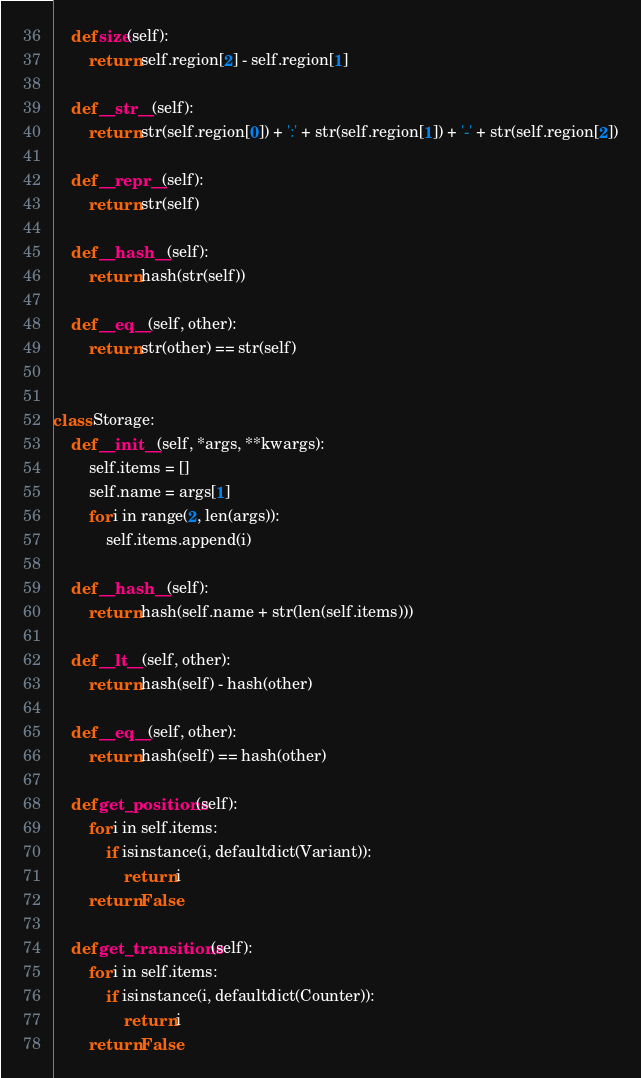<code> <loc_0><loc_0><loc_500><loc_500><_Python_>
    def size(self):
        return self.region[2] - self.region[1]

    def __str__(self):
        return str(self.region[0]) + ':' + str(self.region[1]) + '-' + str(self.region[2])

    def __repr__(self):
        return str(self)

    def __hash__(self):
        return hash(str(self))

    def __eq__(self, other):
        return str(other) == str(self)


class Storage:
    def __init__(self, *args, **kwargs):
        self.items = []
        self.name = args[1]
        for i in range(2, len(args)):
            self.items.append(i)

    def __hash__(self):
        return hash(self.name + str(len(self.items)))

    def __lt__(self, other):
        return hash(self) - hash(other)

    def __eq__(self, other):
        return hash(self) == hash(other)

    def get_positions(self):
        for i in self.items:
            if isinstance(i, defaultdict(Variant)):
                return i
        return False

    def get_transitions(self):
        for i in self.items:
            if isinstance(i, defaultdict(Counter)):
                return i
        return False
</code> 